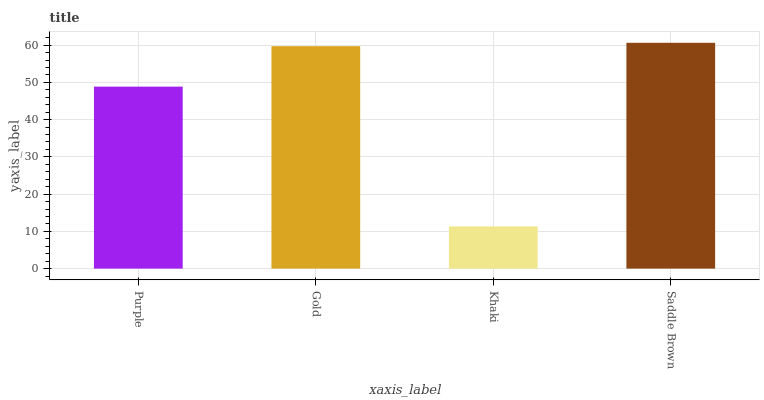Is Khaki the minimum?
Answer yes or no. Yes. Is Saddle Brown the maximum?
Answer yes or no. Yes. Is Gold the minimum?
Answer yes or no. No. Is Gold the maximum?
Answer yes or no. No. Is Gold greater than Purple?
Answer yes or no. Yes. Is Purple less than Gold?
Answer yes or no. Yes. Is Purple greater than Gold?
Answer yes or no. No. Is Gold less than Purple?
Answer yes or no. No. Is Gold the high median?
Answer yes or no. Yes. Is Purple the low median?
Answer yes or no. Yes. Is Saddle Brown the high median?
Answer yes or no. No. Is Khaki the low median?
Answer yes or no. No. 